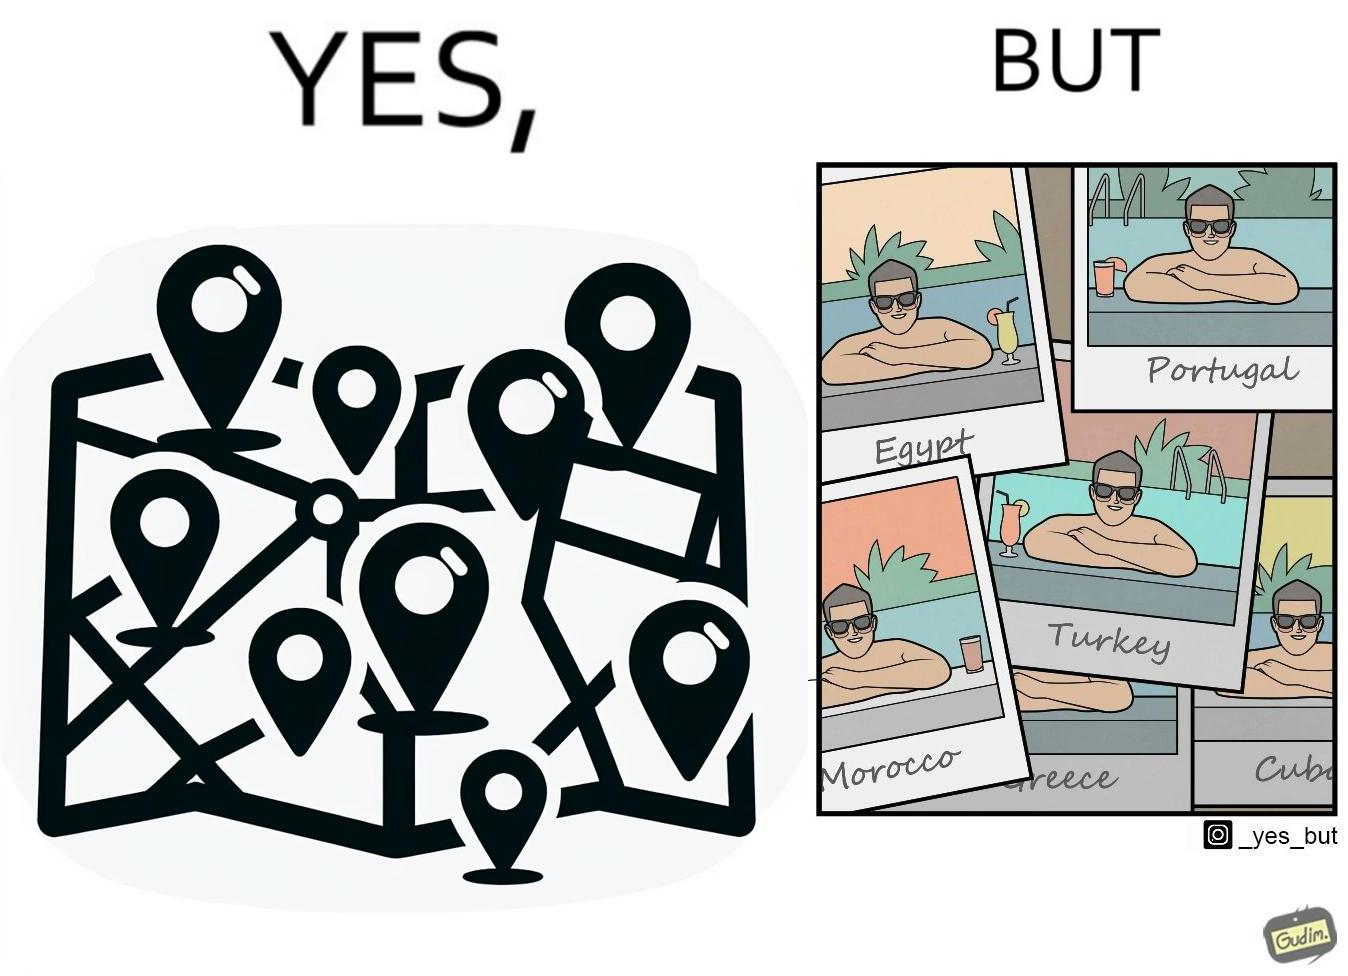What is shown in the left half versus the right half of this image? In the left part of the image: The image shows a map with pins set on places which have been visited by a person. In the right part of the image: The image shows several photos of a man wearing sunglasses  inside a pool in various countries like Egypt, Portugal, Morocco, Turkey, Greece and Cuba. 